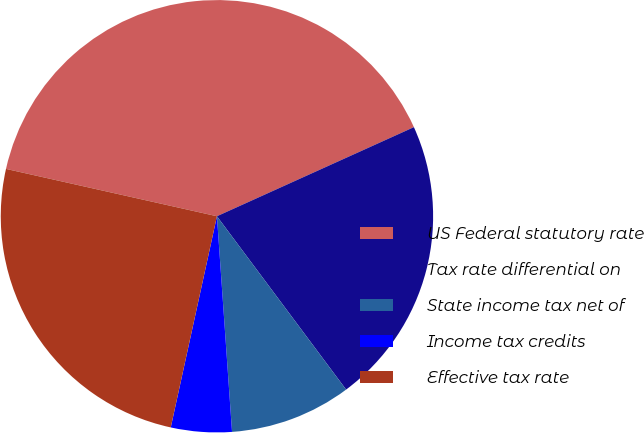Convert chart. <chart><loc_0><loc_0><loc_500><loc_500><pie_chart><fcel>US Federal statutory rate<fcel>Tax rate differential on<fcel>State income tax net of<fcel>Income tax credits<fcel>Effective tax rate<nl><fcel>39.73%<fcel>21.57%<fcel>9.08%<fcel>4.54%<fcel>25.09%<nl></chart> 